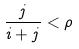Convert formula to latex. <formula><loc_0><loc_0><loc_500><loc_500>\frac { j } { i + j } < \rho</formula> 